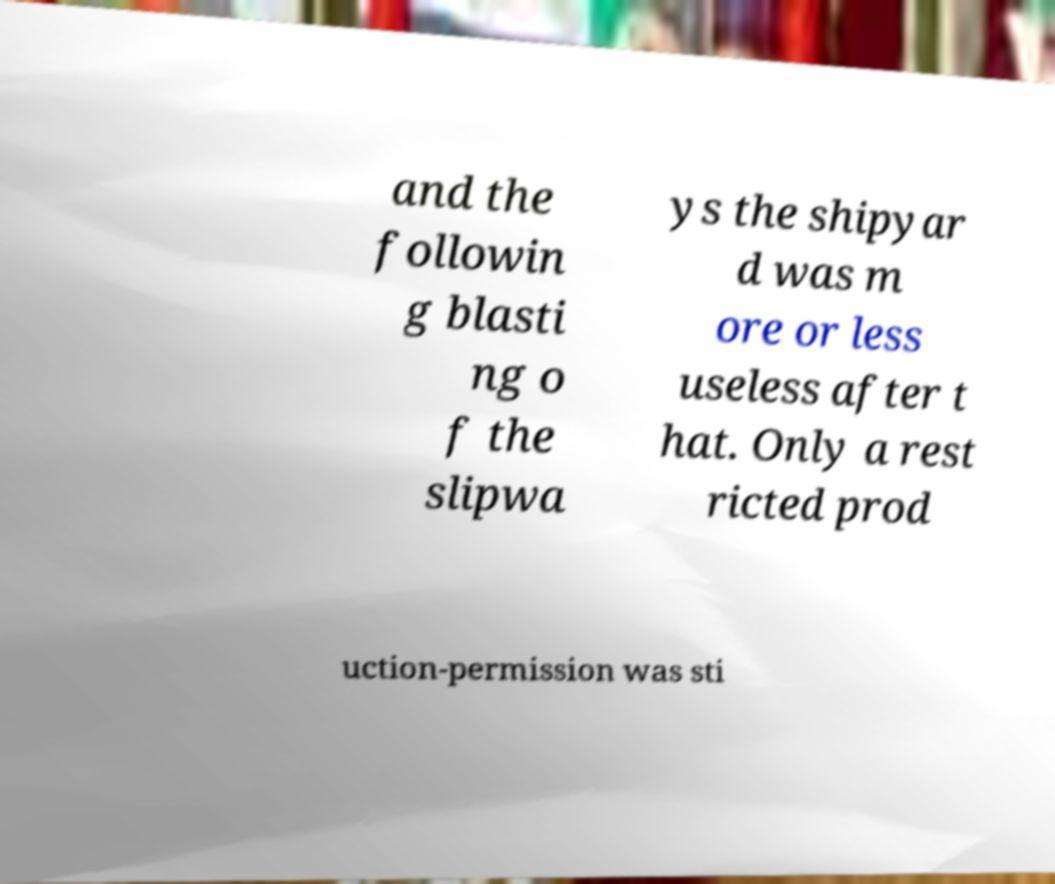Could you assist in decoding the text presented in this image and type it out clearly? and the followin g blasti ng o f the slipwa ys the shipyar d was m ore or less useless after t hat. Only a rest ricted prod uction-permission was sti 